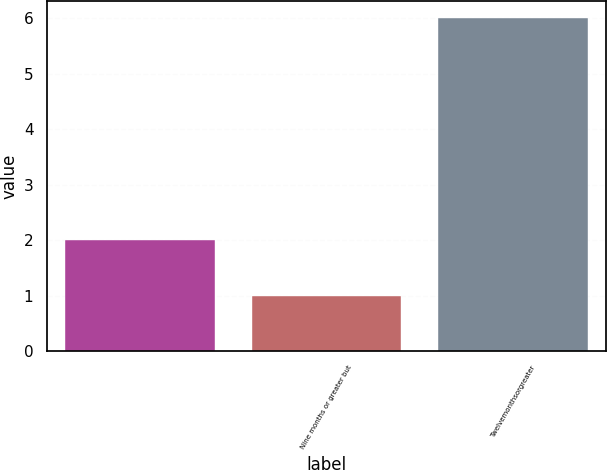Convert chart to OTSL. <chart><loc_0><loc_0><loc_500><loc_500><bar_chart><ecel><fcel>Nine months or greater but<fcel>Twelvemonthsorgreater<nl><fcel>2<fcel>1<fcel>6<nl></chart> 